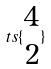<formula> <loc_0><loc_0><loc_500><loc_500>t s \{ \begin{matrix} 4 \\ 2 \end{matrix} \}</formula> 